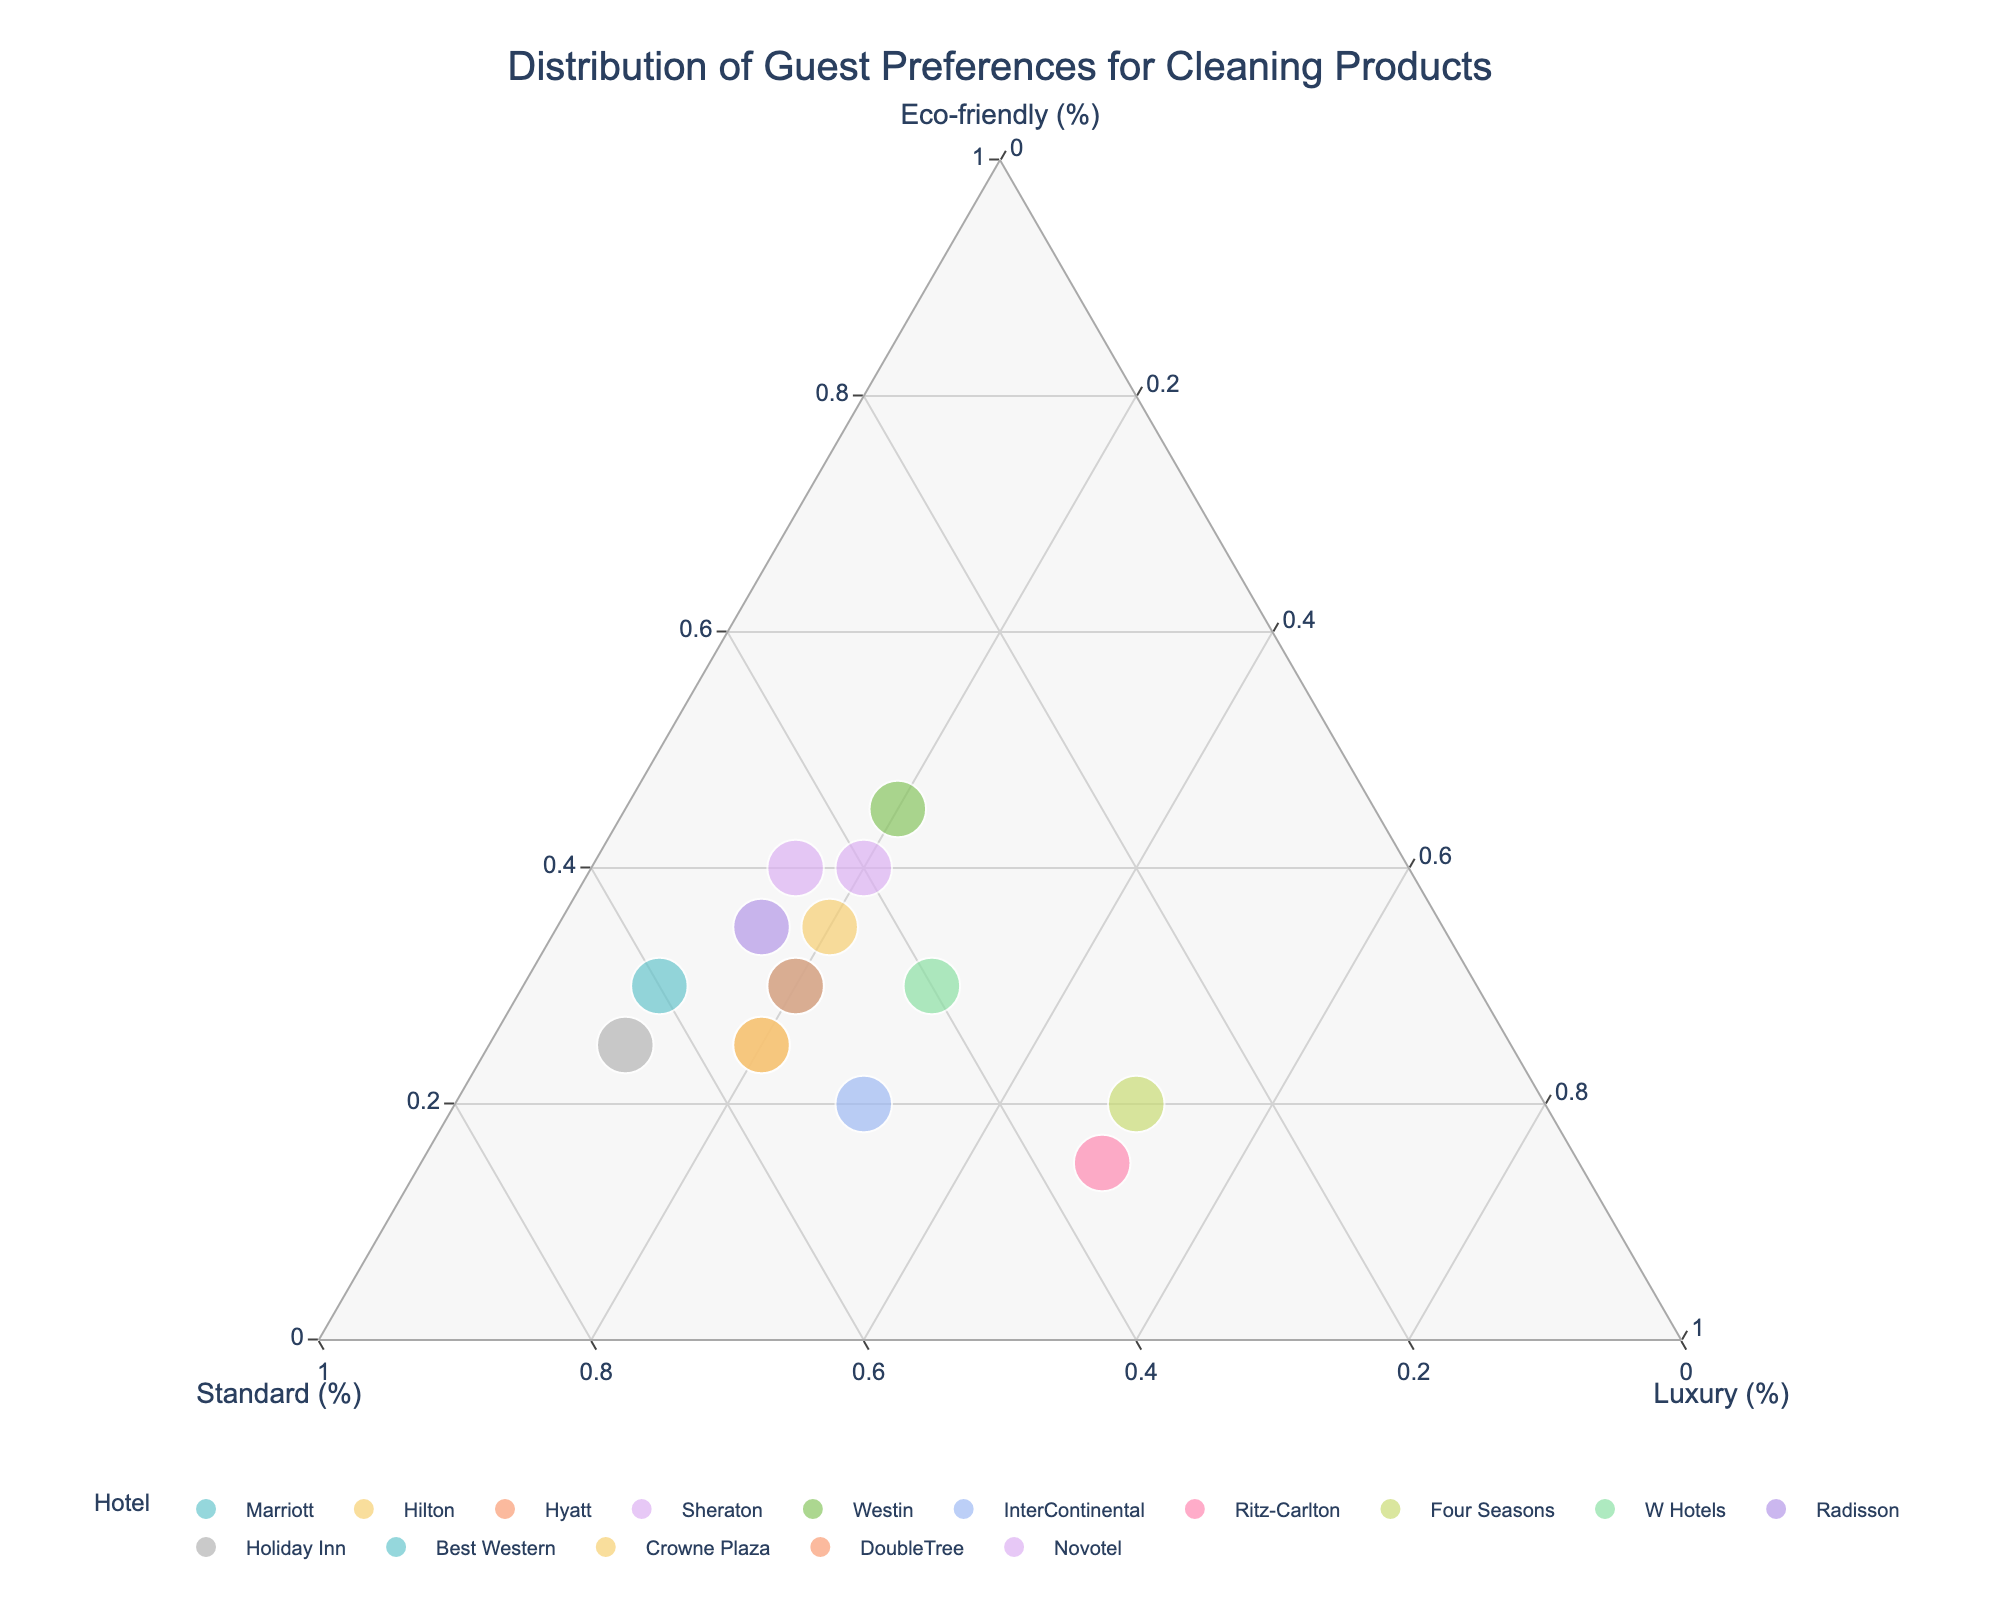What is the title of the plot? The title of the plot is located at the top and directly indicates what the chart represents. Here, it reads "Distribution of Guest Preferences for Cleaning Products."
Answer: Distribution of Guest Preferences for Cleaning Products How many hotels have a higher preference for eco-friendly products than standard products? By visually inspecting the plot, hotels that have their data points closer to the 'Eco-friendly' axis than the 'Standard' axis prefer eco-friendly products more. Only the Westin indicates this.
Answer: 1 Which hotel has the highest preference for luxury cleaning products? The hotel whose point is closest to the 'Luxury' axis has the highest preference for luxury cleaning products. In this plot, Ritz-Carlton and Four Seasons have the two highest-values at 50%.
Answer: Ritz-Carlton and Four Seasons Which hotels have an equal distribution for standard and eco-friendly cleaning products? Hotels that lie on the line where the percentages for 'Eco-friendly' and 'Standard' are equal will show equal distribution. From the plot, it's evident that Sheraton (40, 40) and Novotel (40, 45) fall into such categories.
Answer: Sheraton and Novotel What is the general trend in preferences for luxury cleaning products by hotels? Most data points are far away from the 'Luxury' axis and clustered around the 'Eco-friendly' and 'Standard' axes, indicating a trend toward fewer preferences for 'Luxury' products amongst the hotels.
Answer: Less preferred Which hotel has a balanced preference for eco-friendly, standard, and luxury cleaning products? A balanced preference would be close to the center of the plot where all the axes meet. W Hotels (30, 40, 30) shows a nearly balanced preference.
Answer: W Hotels Among the listed hotels, which pair has the largest difference in eco-friendly product preference? Visually, the pair with the furthest separation along the 'Eco-friendly' axis will have the largest difference—Westin (45%) and Ritz-Carlton (15%). The difference is 45 - 15 = 30%.
Answer: Westin and Ritz-Carlton (30%) Are there any hotels that show an equal preference for luxury products? Points that lie on a line parallel to the 'Luxury' axis suggest equal preference for luxury products, here, several hotels show a 20% preference, and two show 50% luxury preference. Grouping those and checking counts results in six hotels showing 20% and two at 50%.
Answer: Yes, (20%) six hotels and (50%) two hotels What is the average preference for standard cleaning products across all hotels? Summing up the 'Standard' percentages from all data points and dividing by the total number of hotels gives us the average. Total standard preference is 50 + 45 + 55 + 40 + 35 + 50 + 35 + 30 + 40 + 50 + 65 + 60 + 55 + 50 + 45 = 705; there are 15 hotels, so 705 / 15 = 47.
Answer: 47 